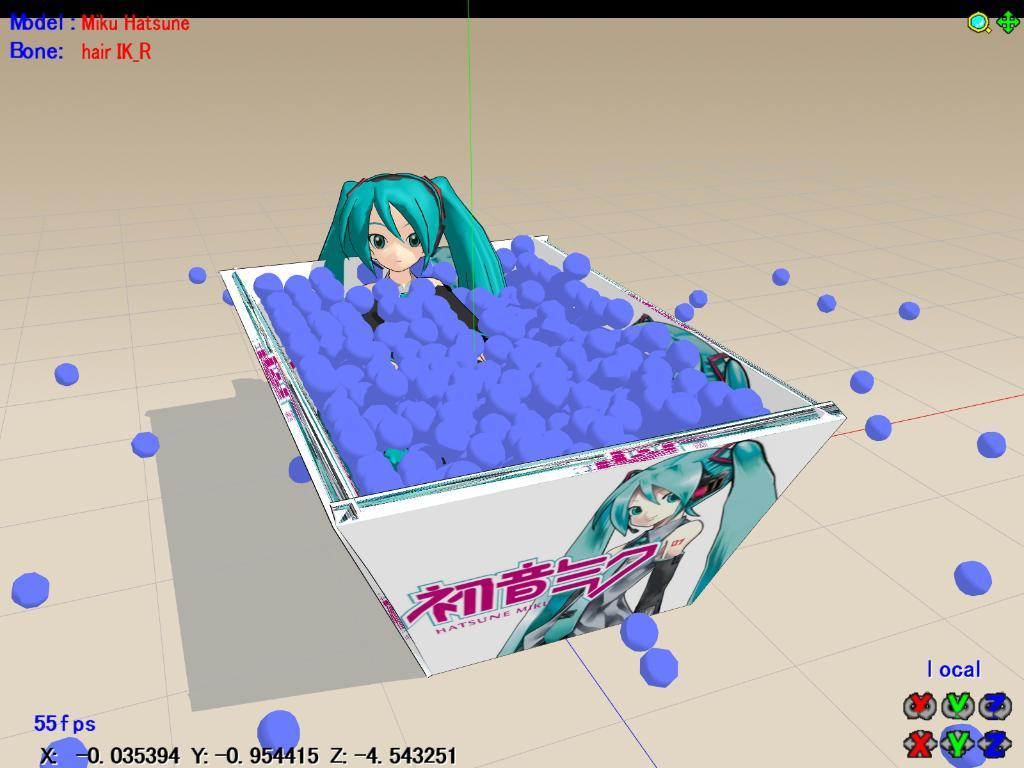What type of image is this? The image is animated. What is the girl doing in the image? The girl is sitting in a bathtub. What is in the bathtub with the girl? There are blue balls in the bathtub. What is happening with some of the balls in the image? Some balls are falling out of the bathtub. Who is the expert in the image? There is no expert present in the image. What appliance is being used in the image? There is no appliance being used in the image. 